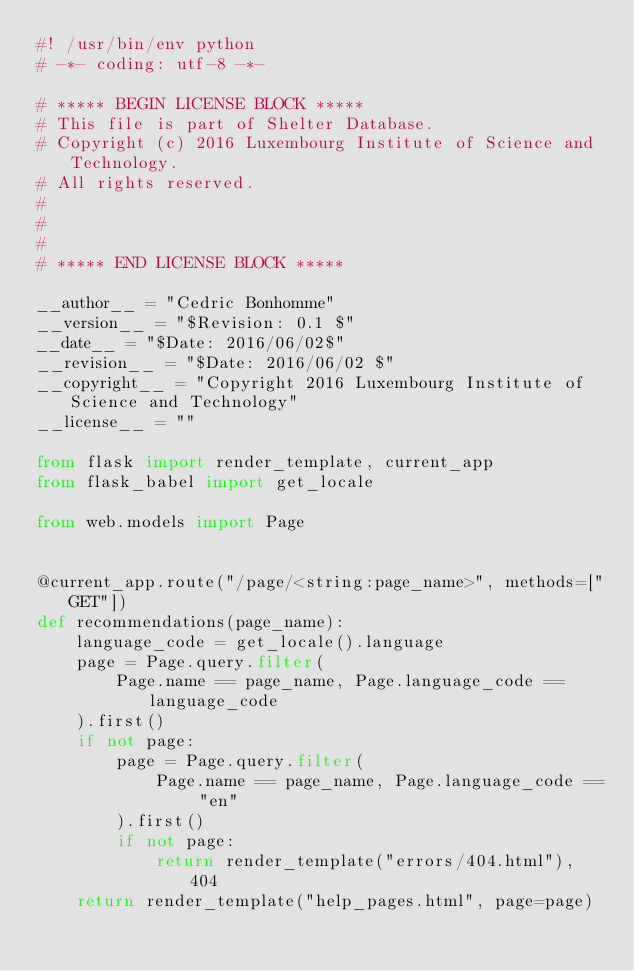<code> <loc_0><loc_0><loc_500><loc_500><_Python_>#! /usr/bin/env python
# -*- coding: utf-8 -*-

# ***** BEGIN LICENSE BLOCK *****
# This file is part of Shelter Database.
# Copyright (c) 2016 Luxembourg Institute of Science and Technology.
# All rights reserved.
#
#
#
# ***** END LICENSE BLOCK *****

__author__ = "Cedric Bonhomme"
__version__ = "$Revision: 0.1 $"
__date__ = "$Date: 2016/06/02$"
__revision__ = "$Date: 2016/06/02 $"
__copyright__ = "Copyright 2016 Luxembourg Institute of Science and Technology"
__license__ = ""

from flask import render_template, current_app
from flask_babel import get_locale

from web.models import Page


@current_app.route("/page/<string:page_name>", methods=["GET"])
def recommendations(page_name):
    language_code = get_locale().language
    page = Page.query.filter(
        Page.name == page_name, Page.language_code == language_code
    ).first()
    if not page:
        page = Page.query.filter(
            Page.name == page_name, Page.language_code == "en"
        ).first()
        if not page:
            return render_template("errors/404.html"), 404
    return render_template("help_pages.html", page=page)
</code> 